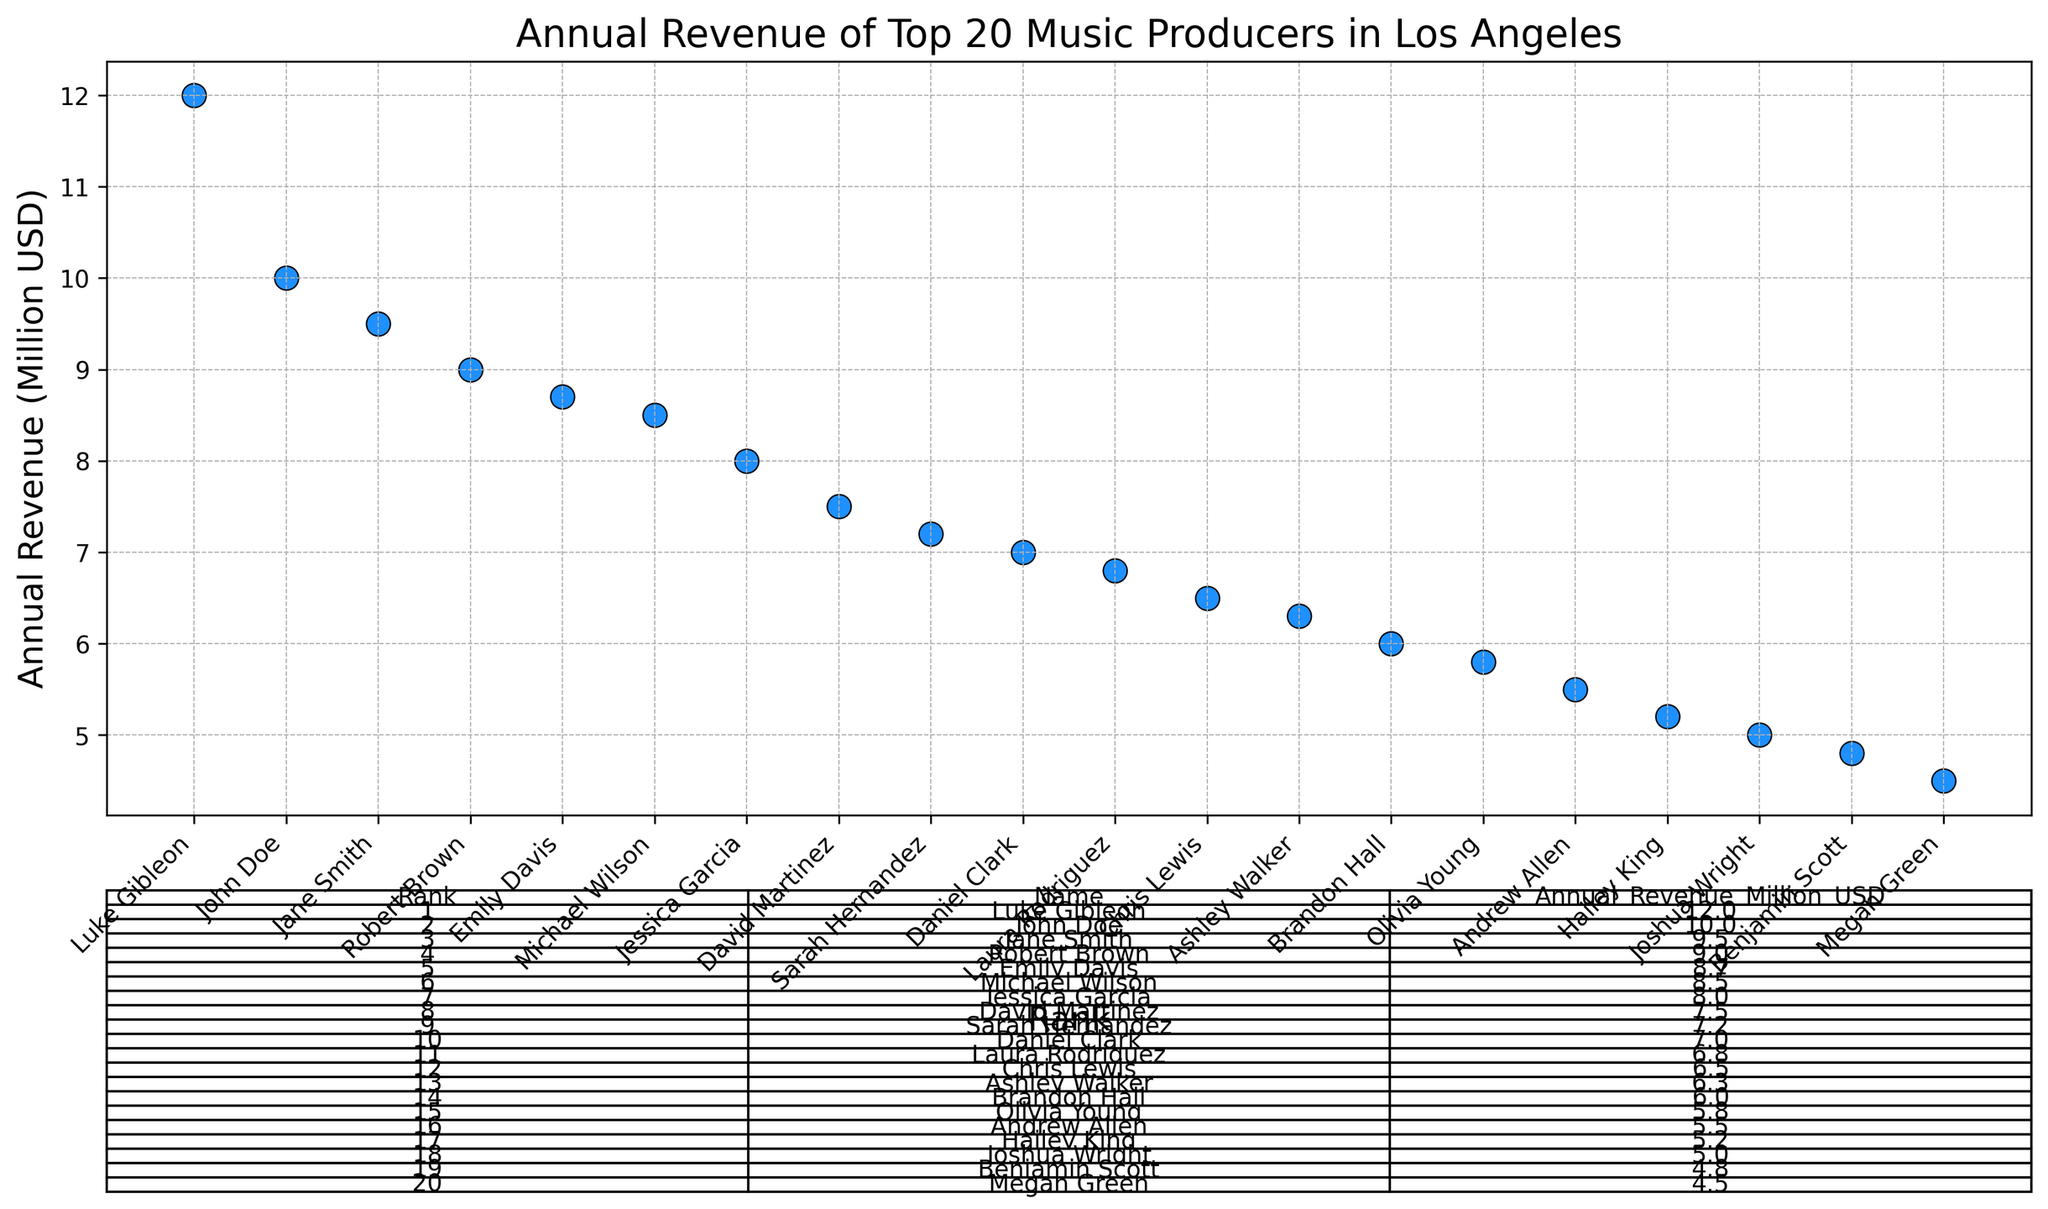How much more annual revenue does Luke Gibleon make compared to Megan Green? First, find Luke's revenue, which is $12 million, and Megan's revenue, which is $4.5 million. Then subtract Megan's revenue from Luke's revenue: $12M - $4.5M = $7.5M.
Answer: $7.5 million Who ranks 10th in annual revenue and how much do they make? Locate the 10th ranked producer on the chart, which is Daniel Clark, who makes $7 million.
Answer: Daniel Clark, $7 million What is the total annual revenue of the top 3 music producers in Los Angeles? Sum the revenues of the top three producers: Luke Gibleon ($12M) + John Doe ($10M) + Jane Smith ($9.5M) = $31.5M.
Answer: $31.5 million How does the 5th highest annual revenue compare to the 15th highest? Identify the 5th highest revenue (Emily Davis, $8.7 million) and the 15th highest revenue (Olivia Young, $5.8 million). Compare the two: $8.7M > $5.8M.
Answer: Emily Davis earns $2.9 million more than Olivia Young Who are the producers with revenues above $9 million? Check the chart for producers with revenues above $9 million: Luke Gibleon ($12M), John Doe ($10M), Jane Smith ($9.5M), and Robert Brown ($9M).
Answer: Luke Gibleon, John Doe, Jane Smith, Robert Brown What is the average annual revenue of all top 20 music producers? Sum the revenues of all 20 producers and divide by 20. Total revenue = $142.3 million. Average = $142.3M / 20 = $7.115M.
Answer: $7.115 million What is the range of annual revenues among the top 20 music producers? Identify the highest revenue (Luke Gibleon, $12M) and the lowest revenue (Megan Green, $4.5M). Range = $12M - $4.5M = $7.5M.
Answer: $7.5 million Which rank does Chris Lewis hold and what is his annual revenue? Look at the chart to find Chris Lewis' rank, which is 12th, and his revenue, which is $6.5 million.
Answer: 12th, $6.5 million How many producers have a revenue between $5 million and $7 million? Count the producers within this range: Daniel Clark ($7M), Laura Rodriguez ($6.8M), Chris Lewis ($6.5M), Ashley Walker ($6.3M), Brandon Hall ($6M), Olivia Young ($5.8M), Andrew Allen ($5.5M), Hailey King ($5.2M), Joshua Wright ($5M). Total = 9 producers.
Answer: 9 Which producer ranks right before Hailey King and how much is their revenue? Hailey King ranks 17th. The producer ranked 16th is Andrew Allen, with a revenue of $5.5 million.
Answer: Andrew Allen, $5.5 million 